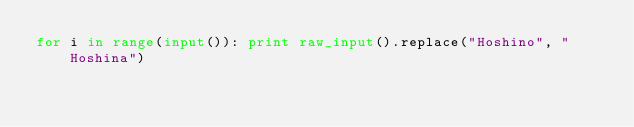Convert code to text. <code><loc_0><loc_0><loc_500><loc_500><_Python_>for i in range(input()): print raw_input().replace("Hoshino", "Hoshina")</code> 